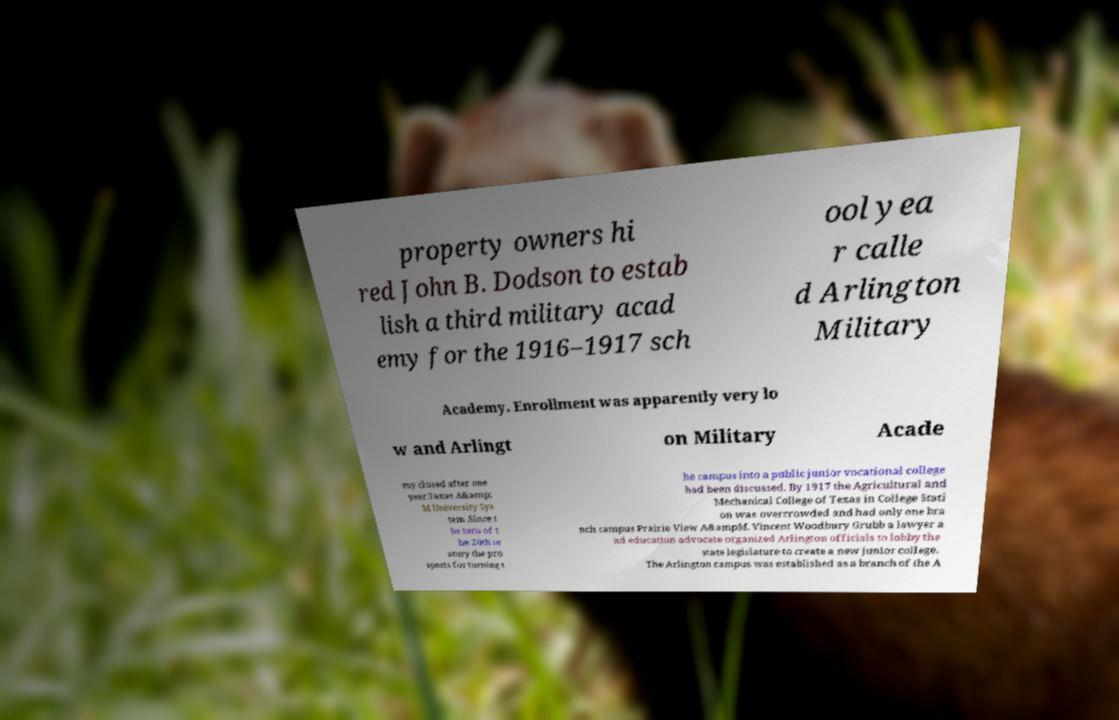Can you accurately transcribe the text from the provided image for me? property owners hi red John B. Dodson to estab lish a third military acad emy for the 1916–1917 sch ool yea r calle d Arlington Military Academy. Enrollment was apparently very lo w and Arlingt on Military Acade my closed after one year.Texas A&amp; M University Sys tem .Since t he turn of t he 20th ce ntury the pro spects for turning t he campus into a public junior vocational college had been discussed. By 1917 the Agricultural and Mechanical College of Texas in College Stati on was overcrowded and had only one bra nch campus Prairie View A&ampM. Vincent Woodbury Grubb a lawyer a nd education advocate organized Arlington officials to lobby the state legislature to create a new junior college. The Arlington campus was established as a branch of the A 